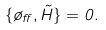<formula> <loc_0><loc_0><loc_500><loc_500>\{ \tau _ { \alpha } , \tilde { H } \} = 0 .</formula> 